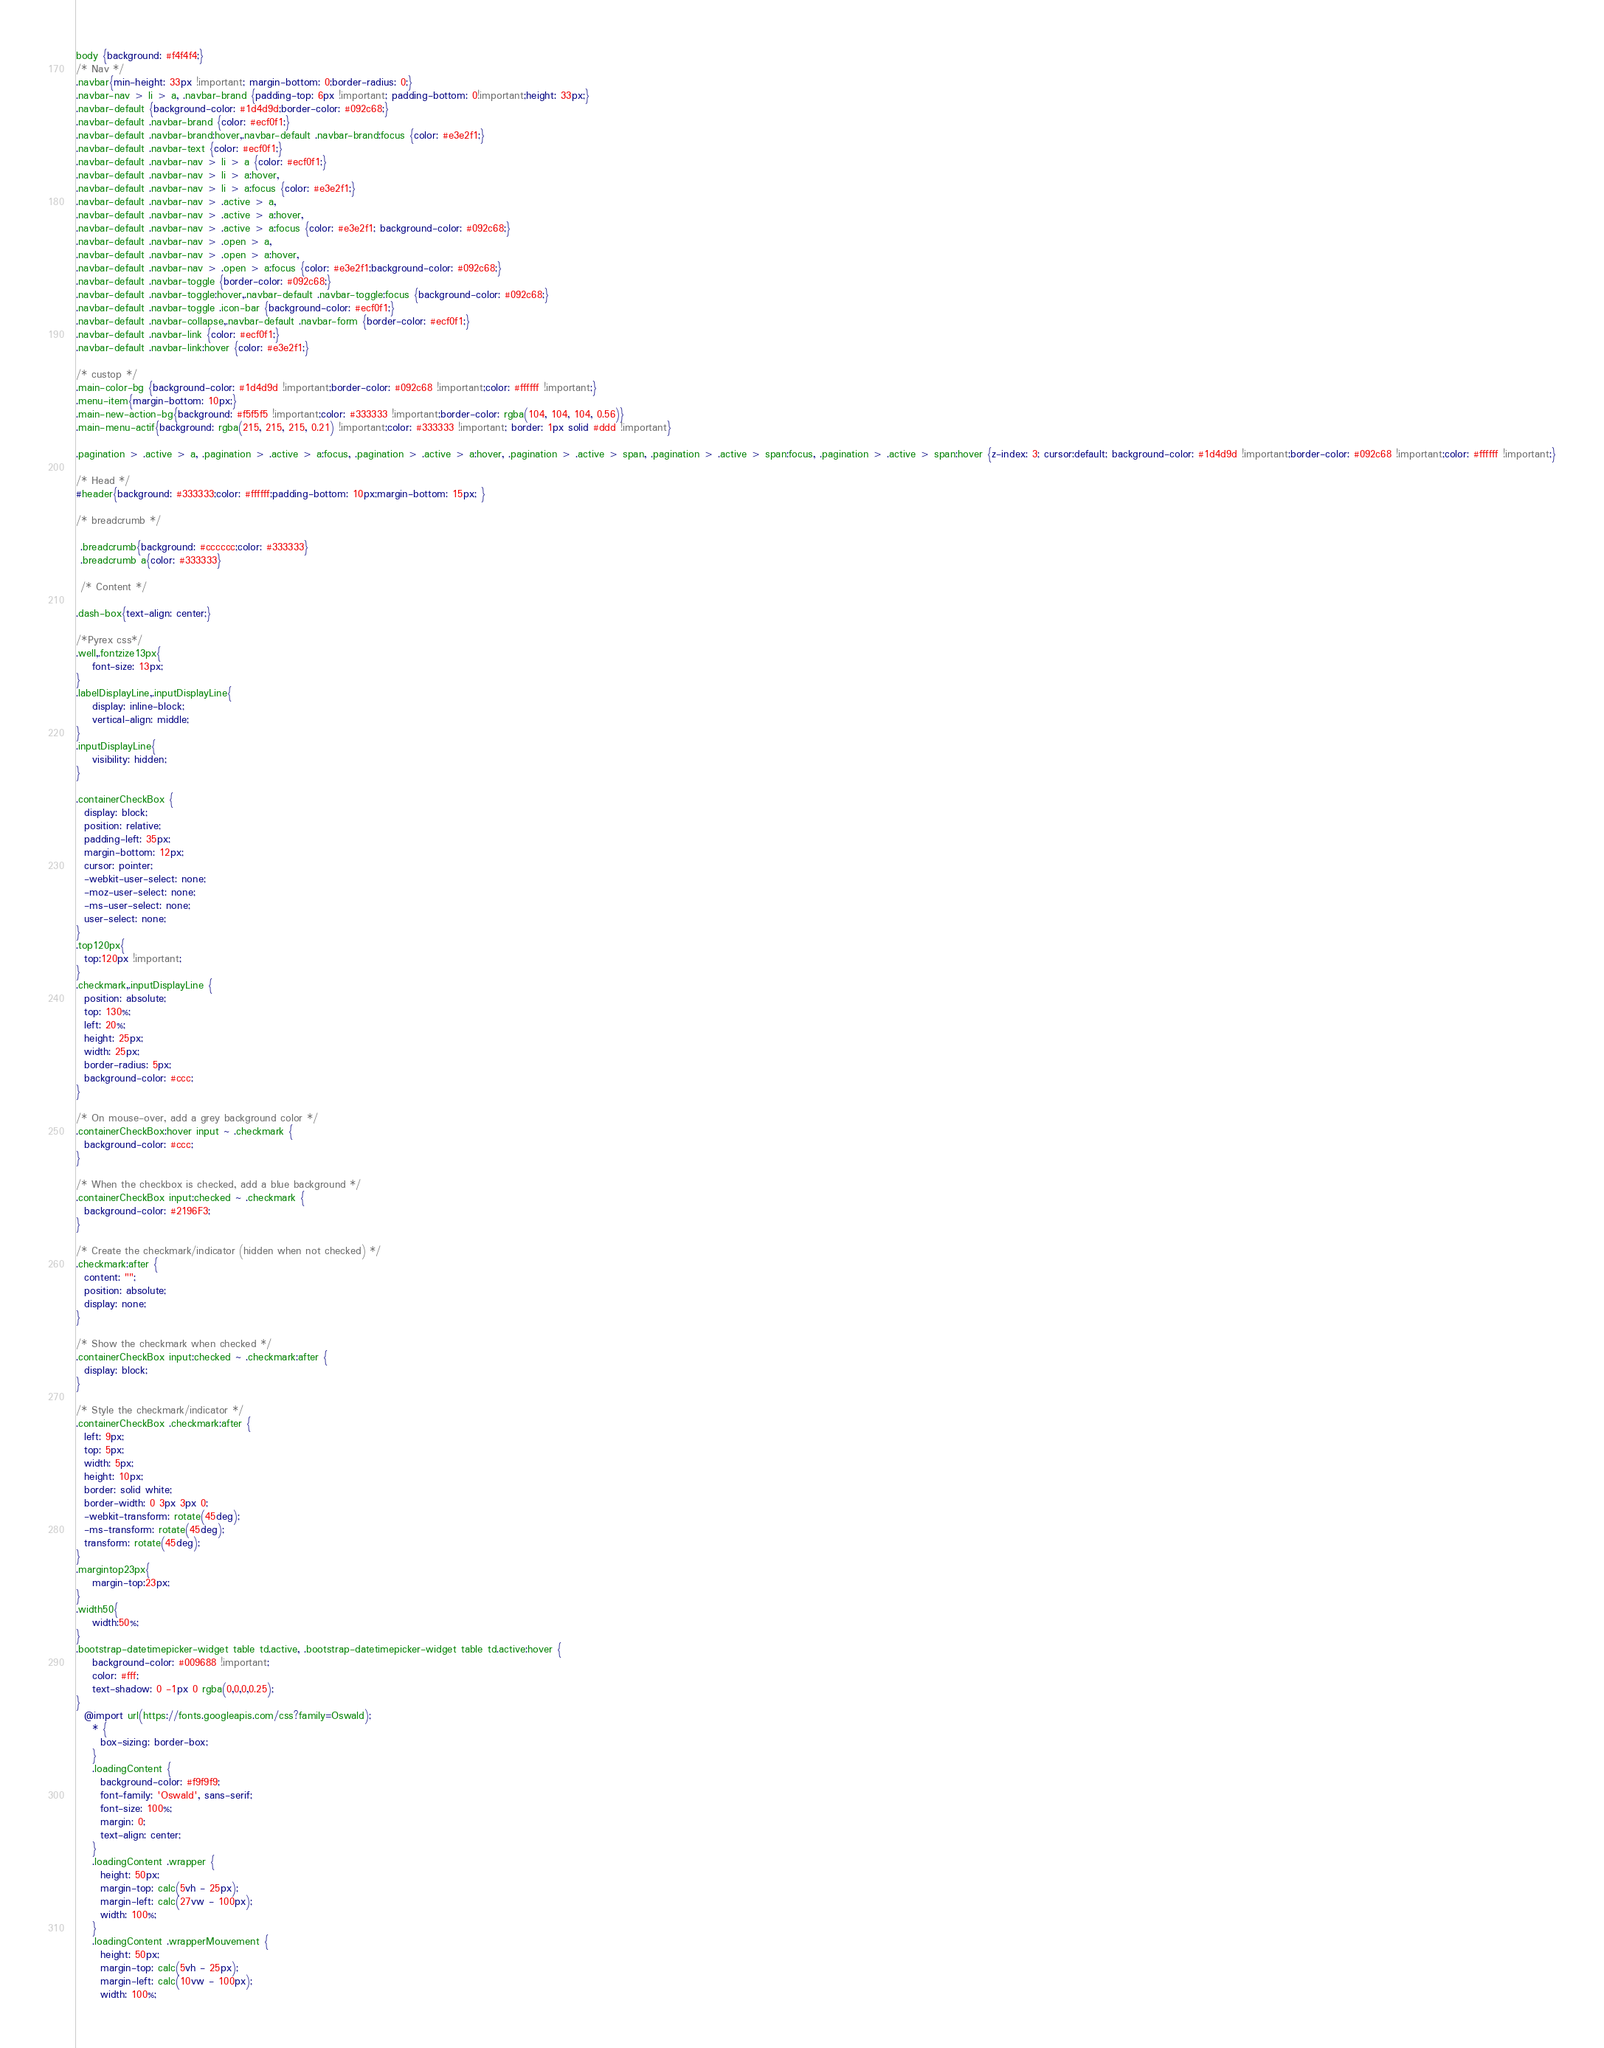<code> <loc_0><loc_0><loc_500><loc_500><_CSS_>body {background: #f4f4f4;}
/* Nav */
.navbar{min-height: 33px !important; margin-bottom: 0;border-radius: 0;}
.navbar-nav > li > a, .navbar-brand {padding-top: 6px !important; padding-bottom: 0!important;height: 33px;}
.navbar-default {background-color: #1d4d9d;border-color: #092c68;}
.navbar-default .navbar-brand {color: #ecf0f1;}
.navbar-default .navbar-brand:hover,.navbar-default .navbar-brand:focus {color: #e3e2f1;}
.navbar-default .navbar-text {color: #ecf0f1;}
.navbar-default .navbar-nav > li > a {color: #ecf0f1;}
.navbar-default .navbar-nav > li > a:hover,
.navbar-default .navbar-nav > li > a:focus {color: #e3e2f1;}
.navbar-default .navbar-nav > .active > a,
.navbar-default .navbar-nav > .active > a:hover,
.navbar-default .navbar-nav > .active > a:focus {color: #e3e2f1; background-color: #092c68;}
.navbar-default .navbar-nav > .open > a,
.navbar-default .navbar-nav > .open > a:hover,
.navbar-default .navbar-nav > .open > a:focus {color: #e3e2f1;background-color: #092c68;}
.navbar-default .navbar-toggle {border-color: #092c68;}
.navbar-default .navbar-toggle:hover,.navbar-default .navbar-toggle:focus {background-color: #092c68;}
.navbar-default .navbar-toggle .icon-bar {background-color: #ecf0f1;}
.navbar-default .navbar-collapse,.navbar-default .navbar-form {border-color: #ecf0f1;}
.navbar-default .navbar-link {color: #ecf0f1;}
.navbar-default .navbar-link:hover {color: #e3e2f1;}

/* custop */
.main-color-bg {background-color: #1d4d9d !important;border-color: #092c68 !important;color: #ffffff !important;}
.menu-item{margin-bottom: 10px;}
.main-new-action-bg{background: #f5f5f5 !important;color: #333333 !important;border-color: rgba(104, 104, 104, 0.56)}
.main-menu-actif{background: rgba(215, 215, 215, 0.21) !important;color: #333333 !important; border: 1px solid #ddd !important}

.pagination > .active > a, .pagination > .active > a:focus, .pagination > .active > a:hover, .pagination > .active > span, .pagination > .active > span:focus, .pagination > .active > span:hover {z-index: 3; cursor:default; background-color: #1d4d9d !important;border-color: #092c68 !important;color: #ffffff !important;}

/* Head */
#header{background: #333333;color: #ffffff;padding-bottom: 10px;margin-bottom: 15px; }

/* breadcrumb */

 .breadcrumb{background: #cccccc;color: #333333}
 .breadcrumb a{color: #333333}

 /* Content */

.dash-box{text-align: center;}

/*Pyrex css*/
.well,.fontzize13px{
    font-size: 13px;
}
.labelDisplayLine,.inputDisplayLine{
    display: inline-block;
    vertical-align: middle;
}
.inputDisplayLine{
    visibility: hidden;
}

.containerCheckBox {
  display: block;
  position: relative;
  padding-left: 35px;
  margin-bottom: 12px;
  cursor: pointer;
  -webkit-user-select: none;
  -moz-user-select: none;
  -ms-user-select: none;
  user-select: none;
} 
.top120px{
  top:120px !important;
}
.checkmark,.inputDisplayLine {
  position: absolute;
  top: 130%;
  left: 20%;
  height: 25px;
  width: 25px;
  border-radius: 5px;
  background-color: #ccc;
}

/* On mouse-over, add a grey background color */
.containerCheckBox:hover input ~ .checkmark {
  background-color: #ccc;
}

/* When the checkbox is checked, add a blue background */
.containerCheckBox input:checked ~ .checkmark {
  background-color: #2196F3;
}

/* Create the checkmark/indicator (hidden when not checked) */
.checkmark:after {
  content: "";
  position: absolute;
  display: none;
}

/* Show the checkmark when checked */
.containerCheckBox input:checked ~ .checkmark:after {
  display: block;
}

/* Style the checkmark/indicator */
.containerCheckBox .checkmark:after {
  left: 9px;
  top: 5px;
  width: 5px;
  height: 10px;
  border: solid white;
  border-width: 0 3px 3px 0;
  -webkit-transform: rotate(45deg);
  -ms-transform: rotate(45deg);
  transform: rotate(45deg);
}
.margintop23px{
    margin-top:23px;
}
.width50{
    width:50%;
}
.bootstrap-datetimepicker-widget table td.active, .bootstrap-datetimepicker-widget table td.active:hover {
    background-color: #009688 !important;
    color: #fff;
    text-shadow: 0 -1px 0 rgba(0,0,0,0.25);
}
  @import url(https://fonts.googleapis.com/css?family=Oswald);
    * {
      box-sizing: border-box;
    }
    .loadingContent {
      background-color: #f9f9f9;
      font-family: 'Oswald', sans-serif;
      font-size: 100%;
      margin: 0;
      text-align: center;
    }
    .loadingContent .wrapper {
      height: 50px;
      margin-top: calc(5vh - 25px);
      margin-left: calc(27vw - 100px);
      width: 100%;
    }
    .loadingContent .wrapperMouvement {
      height: 50px;
      margin-top: calc(5vh - 25px);
      margin-left: calc(10vw - 100px);
      width: 100%;</code> 